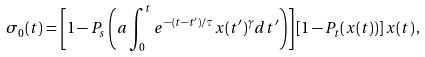<formula> <loc_0><loc_0><loc_500><loc_500>\sigma _ { 0 } ( t ) = \left [ 1 - P _ { s } \left ( a \int _ { 0 } ^ { t } e ^ { - ( t - t ^ { \prime } ) / \tau } x ( t ^ { \prime } ) ^ { \gamma } d t ^ { \prime } \right ) \right ] \left [ 1 - P _ { t } ( x ( t ) ) \right ] x ( t ) \, ,</formula> 